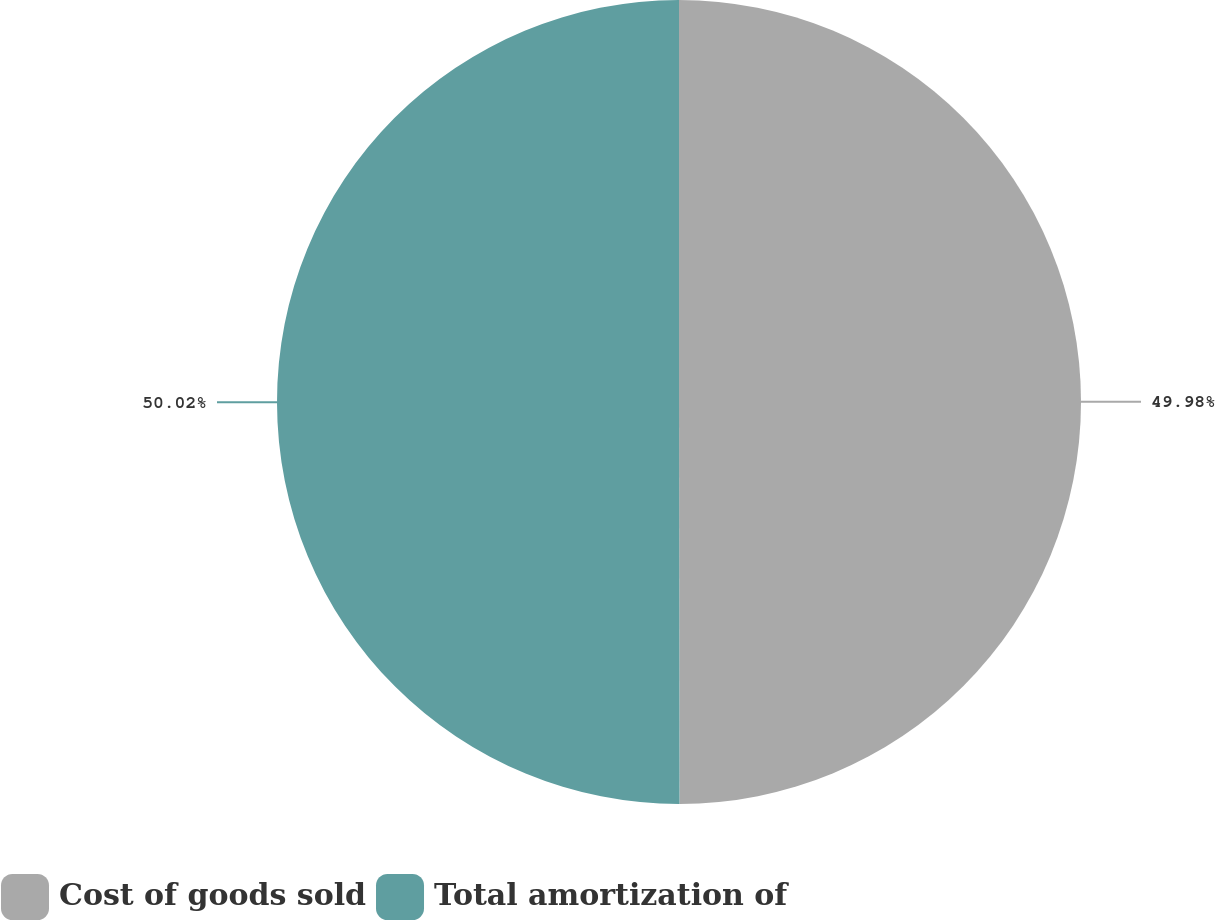Convert chart to OTSL. <chart><loc_0><loc_0><loc_500><loc_500><pie_chart><fcel>Cost of goods sold<fcel>Total amortization of<nl><fcel>49.98%<fcel>50.02%<nl></chart> 